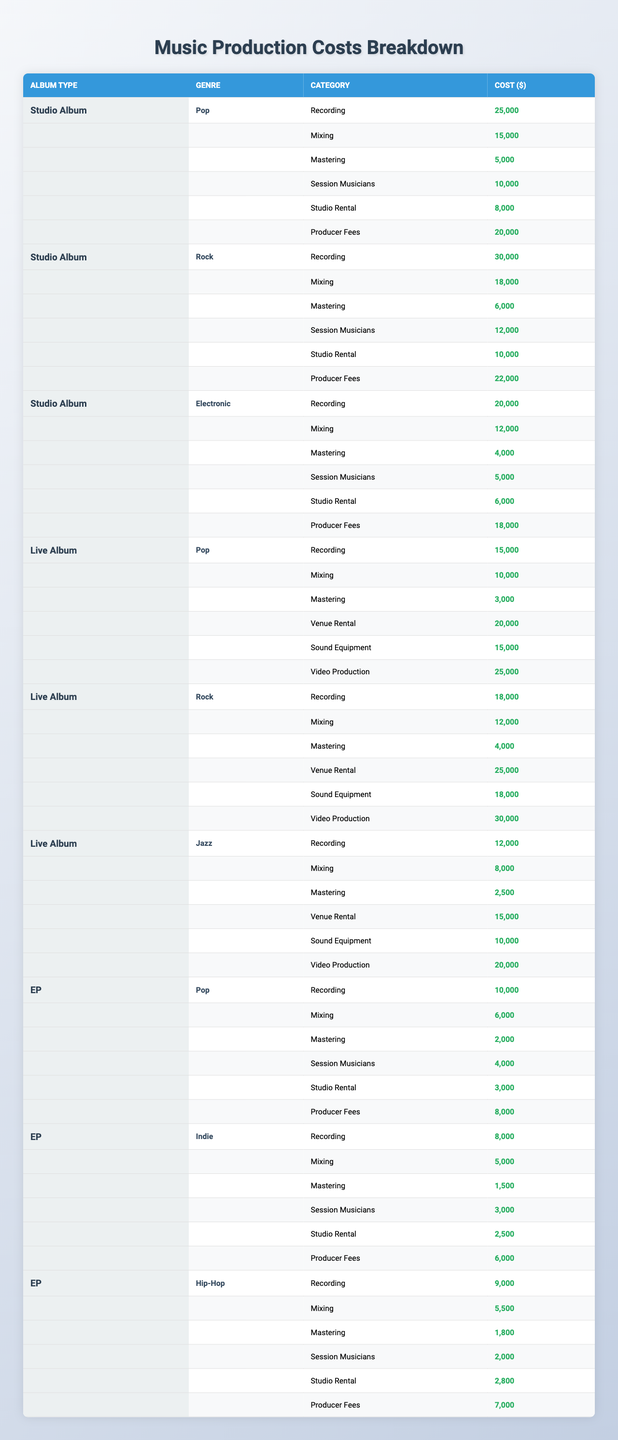What is the total cost of producing a Pop Studio Album? Adding all the costs for a Pop Studio Album: Recording ($25,000) + Mixing ($15,000) + Mastering ($5,000) + Session Musicians ($10,000) + Studio Rental ($8,000) + Producer Fees ($20,000) = $83,000.
Answer: $83,000 What are the producer fees for a Rock Live Album? The table shows that the producer fees for a Rock Live Album is not listed, thus it is generally not applicable.
Answer: Not applicable Which album type has the highest cost for Sound Equipment in the Jazz genre? The only album type with a Jazz genre listed is Live Album, which allocates $10,000 for Sound Equipment. There are no other entries for Jazz in different album types.
Answer: Live Album What are the total costs for producing an EP in the Indie genre? Summing all costs for an Indie EP: Recording ($8,000) + Mixing ($5,000) + Mastering ($1,500) + Session Musicians ($3,000) + Studio Rental ($2,500) + Producer Fees ($6,000) = $26,000.
Answer: $26,000 Is mixing for Electronic Studio Albums cheaper than the mixing for Rock Studio Albums? The cost for Mixing in Electronic Studio Albums is $12,000 compared to Rock Studio Albums' Mixing cost of $18,000. Since $12,000 is less than $18,000, the statement is true.
Answer: Yes How much more does it cost to produce a Rock Live Album compared to a Pop Live Album? The total cost for a Rock Live Album is: Recording ($18,000) + Mixing ($12,000) + Mastering ($4,000) + Venue Rental ($25,000) + Sound Equipment ($18,000) + Video Production ($30,000) = $107,000. For a Pop Live Album, it is: Recording ($15,000) + Mixing ($10,000) + Mastering ($3,000) + Venue Rental ($20,000) + Sound Equipment ($15,000) + Video Production ($25,000) = $83,000. The difference is $107,000 - $83,000 = $24,000.
Answer: $24,000 What is the average cost of mastering across all Studio Albums? Mastering costs are: Pop ($5,000), Rock ($6,000), Electronic ($4,000). Total Mastering cost = $5,000 + $6,000 + $4,000 = $15,000. There are 3 genres, so the average is $15,000 / 3 = $5,000.
Answer: $5,000 Which genre has the highest total production cost for a Studio Album? Total costs for the genres are: Pop = $83,000; Rock = $96,000; Electronic = $62,000. Therefore, Rock has the highest total production cost at $96,000.
Answer: Rock Is it cheaper to produce a Studio Album or an EP for the Hip-Hop genre? The cost of producing a Hip-Hop EP is $27,300 and since no Hip-Hop Studio Album is listed, we cannot make this comparison directly, but Standard Studio Albums generally cost more than EPs.
Answer: Generally EPs are cheaper How does the total cost of producing a Live Album in Jazz compare to that of a Studio Album in Pop? Jazz Live Album = $25,000 (Recording) + $8,000 (Mixing) + $2,500 (Mastering) + $15,000 (Venue Rental) + $10,000 (Sound Equipment) + $20,000 (Video Production) = $80,500. Pop Studio Album = $83,000. Comparing the two, Pop Studio Album is $2,500 more expensive.
Answer: Pop Studio Album is more expensive What is the total cost for Session Musicians in all album types? The total costs are: Pop Studio Album ($10,000) + Rock Studio Album ($12,000) + Electronic Studio Album ($5,000) + Pop Live Album ($0, not listed) + Rock Live Album ($0, not listed) + Jazz Live Album ($0, not listed) + Pop EP ($4,000) + Indie EP ($3,000) + Hip-Hop EP ($2,000) = $36,000.
Answer: $36,000 